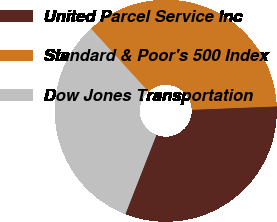Convert chart to OTSL. <chart><loc_0><loc_0><loc_500><loc_500><pie_chart><fcel>United Parcel Service Inc<fcel>Standard & Poor's 500 Index<fcel>Dow Jones Transportation<nl><fcel>31.57%<fcel>36.13%<fcel>32.3%<nl></chart> 